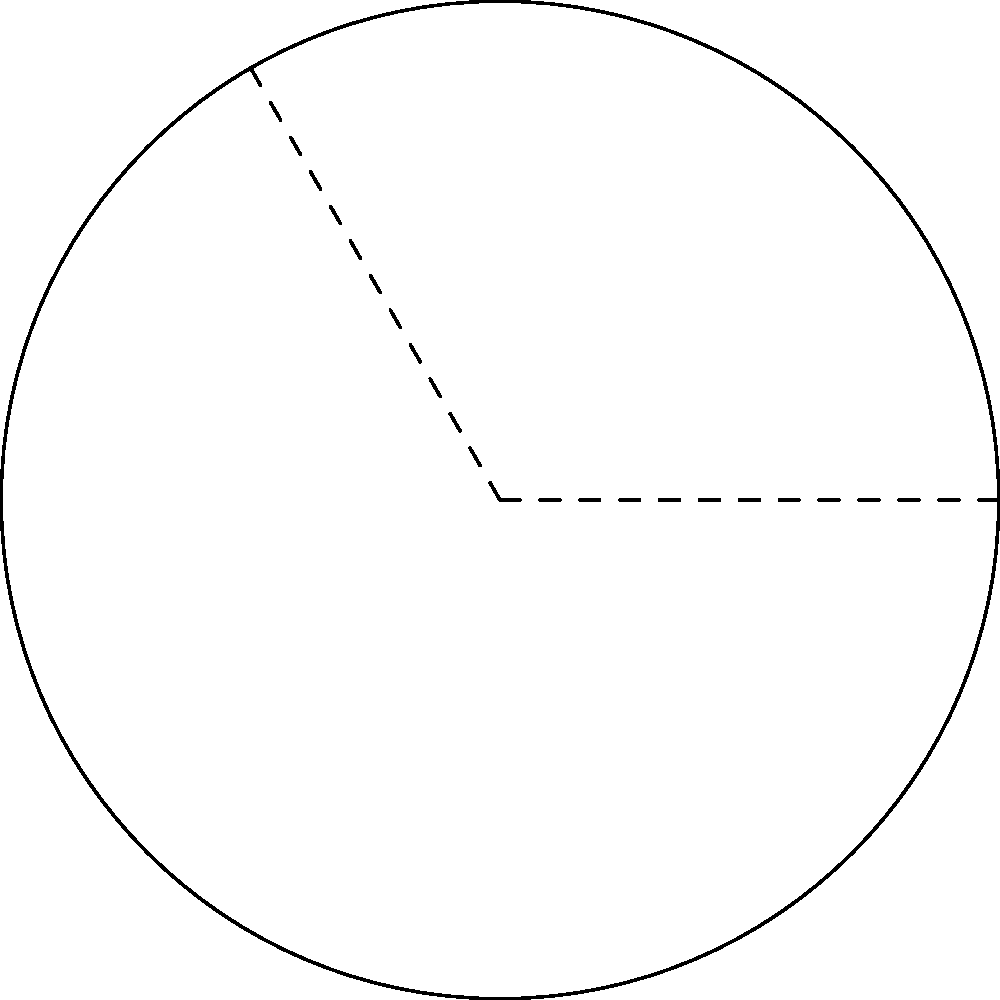At a circular outdoor venue for a Midnight Oil concert, you're tasked with calculating the length of the front-row arc. The stage is at the center of the circle, and the radius of the seating area is 10 meters. If the arc spans an angle of 120°, what is the length of the front-row arc to the nearest tenth of a meter? To solve this problem, we'll use the formula for arc length:

$$ s = r\theta $$

Where:
$s$ = arc length
$r$ = radius of the circle
$\theta$ = angle in radians

Step 1: Convert the angle from degrees to radians.
$\theta = 120° \times \frac{\pi}{180°} = \frac{2\pi}{3}$ radians

Step 2: Apply the arc length formula.
$$ s = r\theta = 10 \times \frac{2\pi}{3} $$

Step 3: Calculate the result.
$$ s = \frac{20\pi}{3} \approx 20.94 \text{ meters} $$

Step 4: Round to the nearest tenth of a meter.
$s \approx 20.9 \text{ meters}$
Answer: 20.9 m 